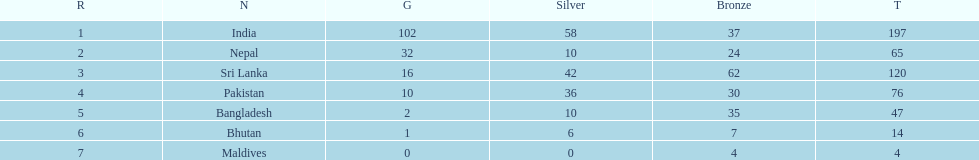In how many countries have the gold medals exceeded 10? 3. 